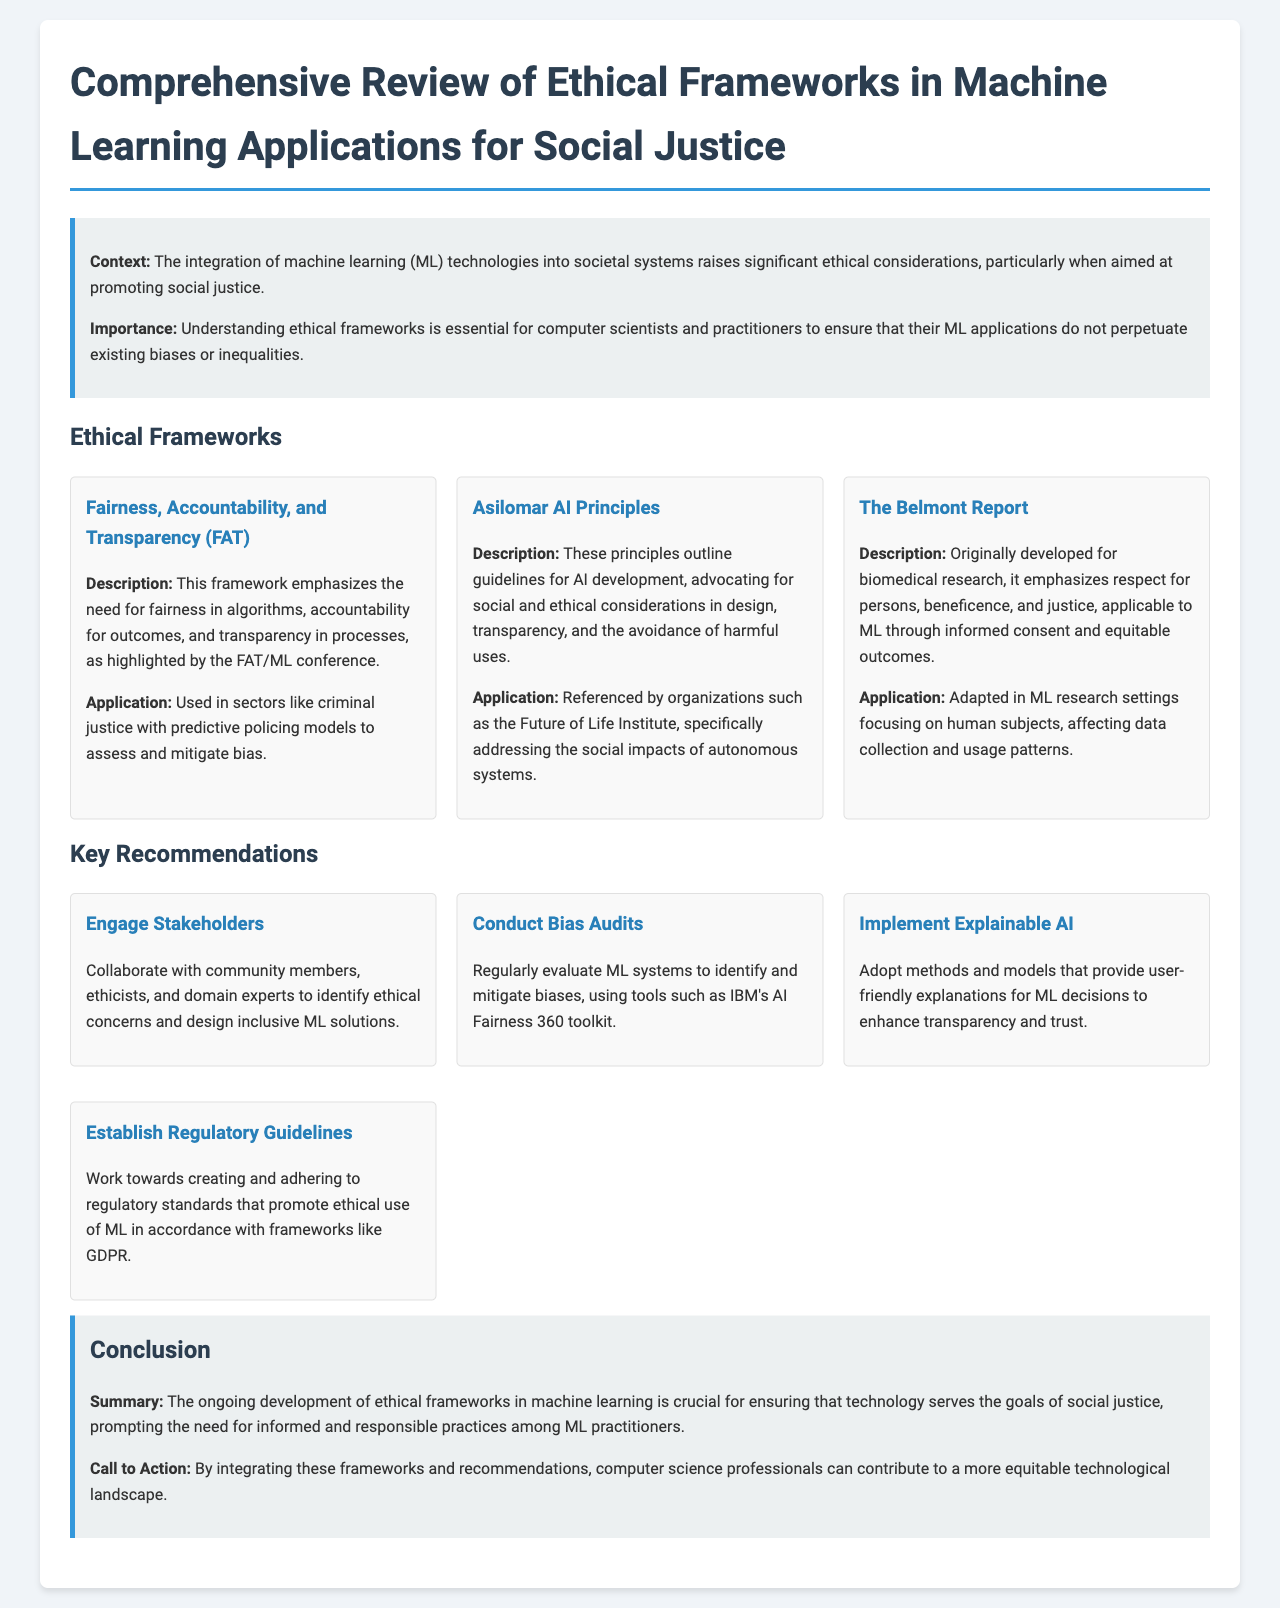What is the title of the document? The title of the document is explicitly stated in the header section.
Answer: Comprehensive Review of Ethical Frameworks in Machine Learning Applications for Social Justice What does FAT stand for? The acronym FAT is explained in the section discussing ethical frameworks.
Answer: Fairness, Accountability, and Transparency Who developed The Belmont Report? The document states that this framework was originally developed for biomedical research.
Answer: Unknown (context suggests it is a known report in ethical guidelines) What is the primary objective of the Asilomar AI Principles? The document describes the Asilomar AI Principles' emphasis on social and ethical considerations in design.
Answer: Advocate for social and ethical considerations Which recommendation involves collaboration with community members? The recommendations section outlines various strategies, including this specific focus on collaboration.
Answer: Engage Stakeholders What is recommended to enhance transparency in ML decisions? The specific recommendation addressing transparency is presented in the key recommendations.
Answer: Implement Explainable AI How many ethical frameworks are discussed in the document? The document lists distinct frameworks under the Ethical Frameworks section.
Answer: Three What is a tool mentioned for conducting bias audits? The recommendation section specifically names tools for evaluating ML systems for bias.
Answer: IBM's AI Fairness 360 toolkit What is the call to action for computer science professionals? The concluding section emphasizes the need for integrating frameworks and recommendations.
Answer: Contribute to a more equitable technological landscape 